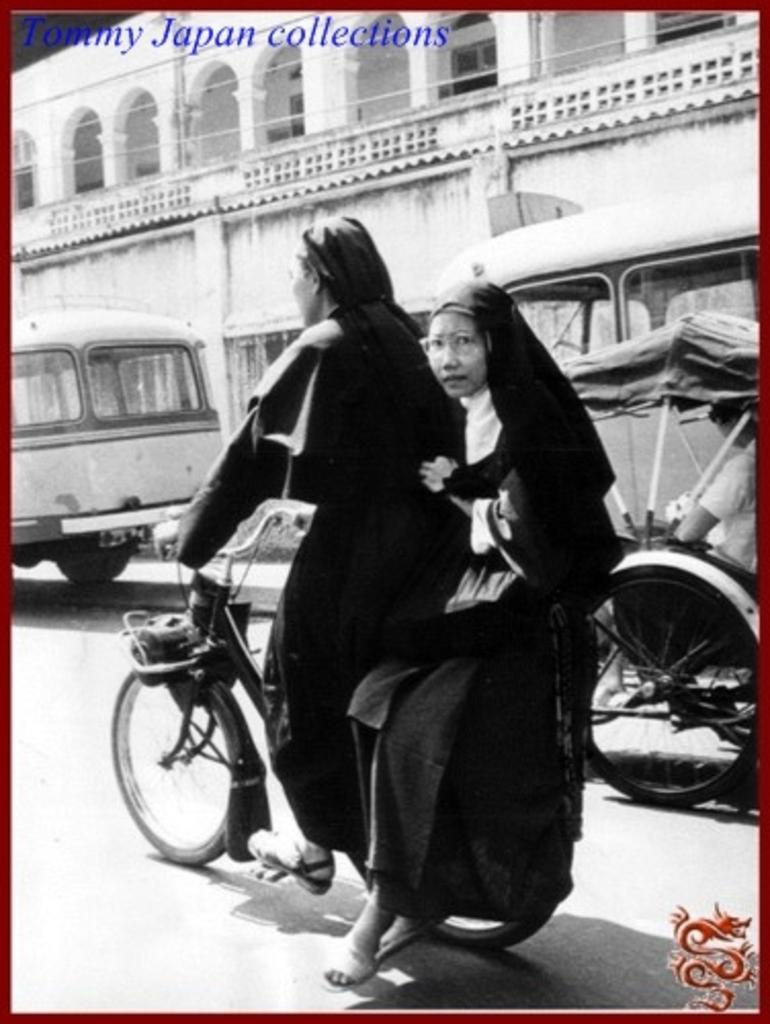Can you describe this image briefly? In this picture we can see one woman riding bicycle and other woman sitting at back of her and we can see some more vehicles such as bus, rickshaw on road and in background we can see building i think this is black and white picture. 